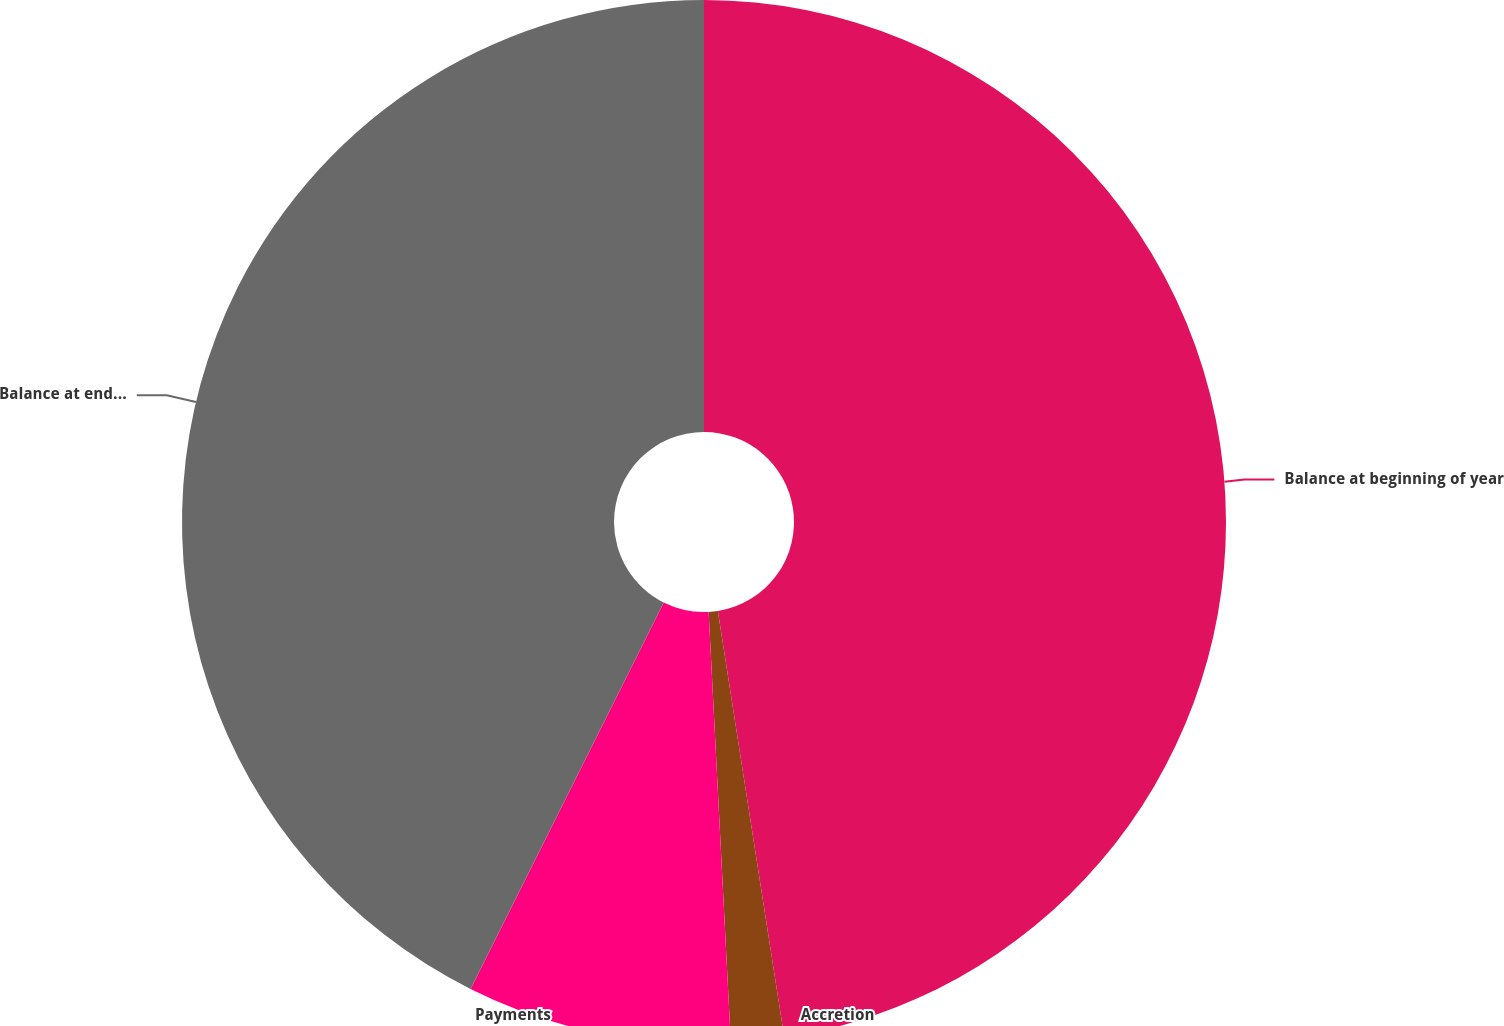Convert chart. <chart><loc_0><loc_0><loc_500><loc_500><pie_chart><fcel>Balance at beginning of year<fcel>Accretion<fcel>Payments<fcel>Balance at end of year<nl><fcel>47.54%<fcel>1.64%<fcel>8.2%<fcel>42.62%<nl></chart> 